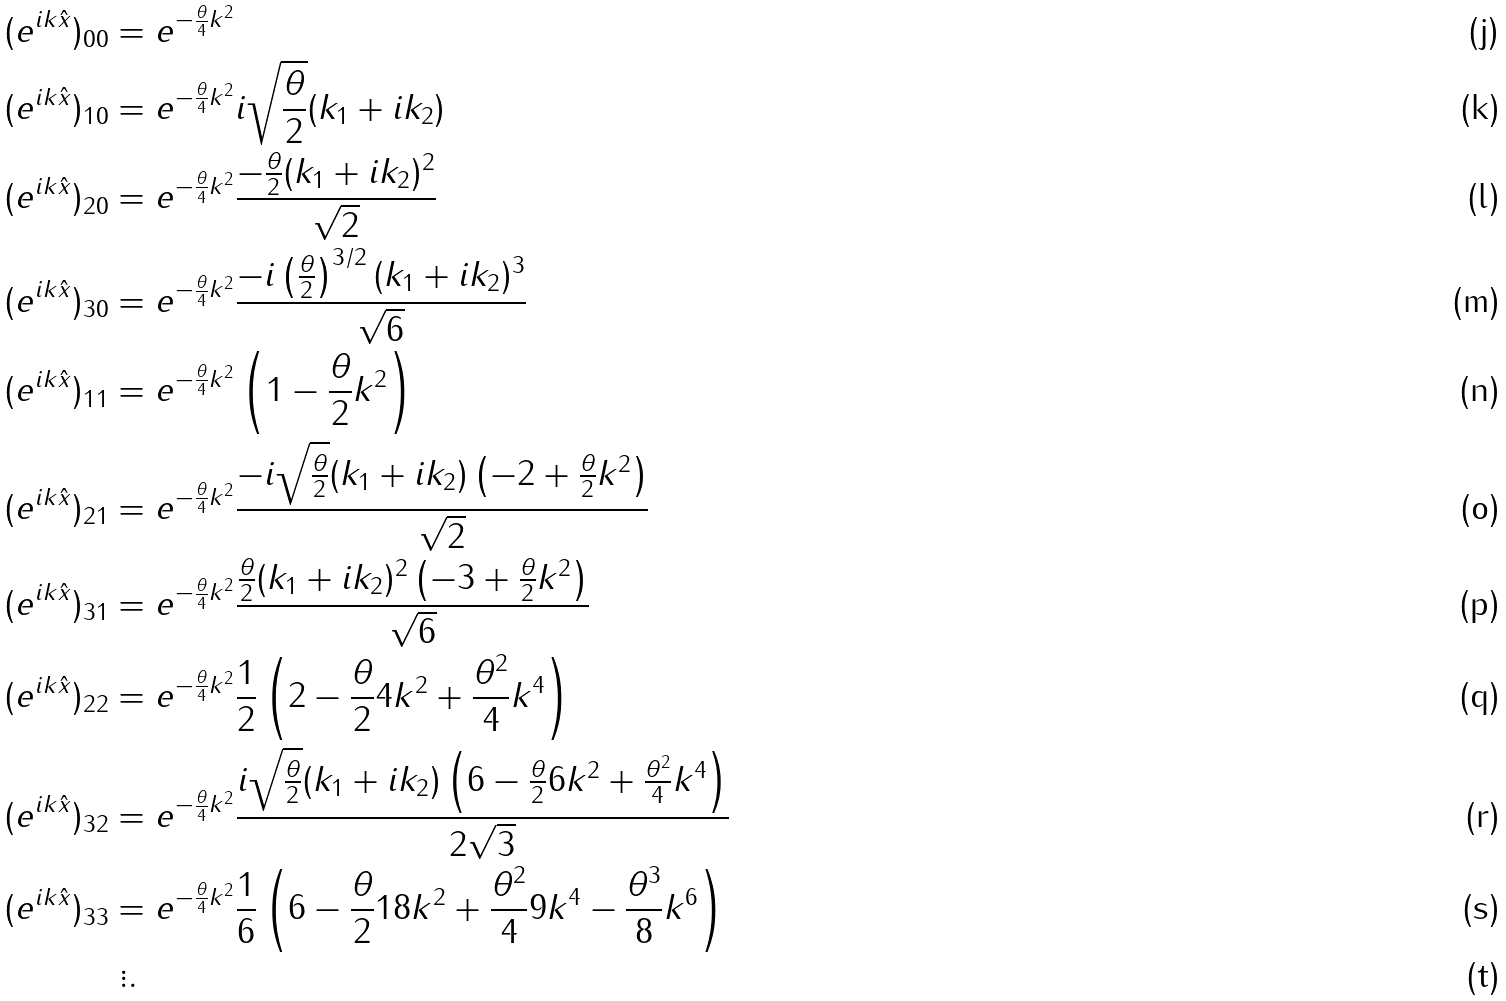<formula> <loc_0><loc_0><loc_500><loc_500>( e ^ { i k \hat { x } } ) _ { 0 0 } & = e ^ { - \frac { \theta } { 4 } k ^ { 2 } } \\ ( e ^ { i k \hat { x } } ) _ { 1 0 } & = e ^ { - \frac { \theta } { 4 } k ^ { 2 } } i \sqrt { \frac { \theta } { 2 } } ( k _ { 1 } + i k _ { 2 } ) \\ ( e ^ { i k \hat { x } } ) _ { 2 0 } & = e ^ { - \frac { \theta } { 4 } k ^ { 2 } } \frac { - \frac { \theta } { 2 } ( k _ { 1 } + i k _ { 2 } ) ^ { 2 } } { \sqrt { 2 } } \\ ( e ^ { i k \hat { x } } ) _ { 3 0 } & = e ^ { - \frac { \theta } { 4 } k ^ { 2 } } \frac { - i \left ( \frac { \theta } { 2 } \right ) ^ { 3 / 2 } ( k _ { 1 } + i k _ { 2 } ) ^ { 3 } } { \sqrt { 6 } } \\ ( e ^ { i k \hat { x } } ) _ { 1 1 } & = e ^ { - \frac { \theta } { 4 } k ^ { 2 } } \left ( 1 - \frac { \theta } { 2 } k ^ { 2 } \right ) \\ ( e ^ { i k \hat { x } } ) _ { 2 1 } & = e ^ { - \frac { \theta } { 4 } k ^ { 2 } } \frac { - i \sqrt { \frac { \theta } { 2 } } ( k _ { 1 } + i k _ { 2 } ) \left ( - 2 + \frac { \theta } { 2 } k ^ { 2 } \right ) } { \sqrt { 2 } } \\ ( e ^ { i k \hat { x } } ) _ { 3 1 } & = e ^ { - \frac { \theta } { 4 } k ^ { 2 } } \frac { \frac { \theta } { 2 } ( k _ { 1 } + i k _ { 2 } ) ^ { 2 } \left ( - 3 + \frac { \theta } { 2 } k ^ { 2 } \right ) } { \sqrt { 6 } } \\ ( e ^ { i k \hat { x } } ) _ { 2 2 } & = e ^ { - \frac { \theta } { 4 } k ^ { 2 } } \frac { 1 } { 2 } \left ( 2 - \frac { \theta } { 2 } 4 k ^ { 2 } + \frac { \theta ^ { 2 } } { 4 } k ^ { 4 } \right ) \\ ( e ^ { i k \hat { x } } ) _ { 3 2 } & = e ^ { - \frac { \theta } { 4 } k ^ { 2 } } \frac { i \sqrt { \frac { \theta } { 2 } } ( k _ { 1 } + i k _ { 2 } ) \left ( 6 - \frac { \theta } { 2 } 6 k ^ { 2 } + \frac { \theta ^ { 2 } } { 4 } k ^ { 4 } \right ) } { 2 \sqrt { 3 } } \\ ( e ^ { i k \hat { x } } ) _ { 3 3 } & = e ^ { - \frac { \theta } { 4 } k ^ { 2 } } \frac { 1 } { 6 } \left ( 6 - \frac { \theta } { 2 } 1 8 k ^ { 2 } + \frac { \theta ^ { 2 } } { 4 } 9 k ^ { 4 } - \frac { \theta ^ { 3 } } { 8 } k ^ { 6 } \right ) \\ & \ \vdots .</formula> 